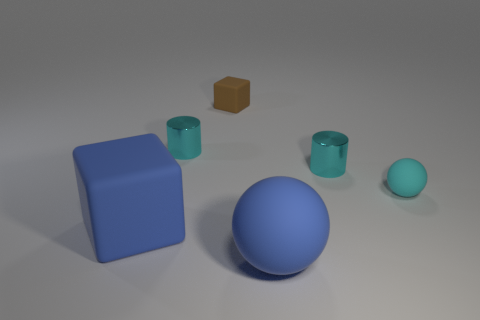Add 4 large blue matte cubes. How many objects exist? 10 Subtract all cylinders. How many objects are left? 4 Add 5 big matte objects. How many big matte objects are left? 7 Add 6 small cyan metal objects. How many small cyan metal objects exist? 8 Subtract 2 cyan cylinders. How many objects are left? 4 Subtract all brown blocks. Subtract all tiny brown cubes. How many objects are left? 4 